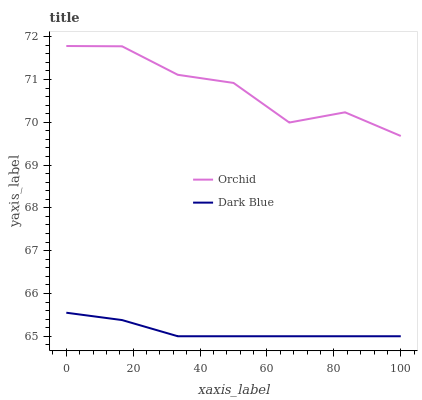Does Dark Blue have the minimum area under the curve?
Answer yes or no. Yes. Does Orchid have the maximum area under the curve?
Answer yes or no. Yes. Does Orchid have the minimum area under the curve?
Answer yes or no. No. Is Dark Blue the smoothest?
Answer yes or no. Yes. Is Orchid the roughest?
Answer yes or no. Yes. Is Orchid the smoothest?
Answer yes or no. No. Does Dark Blue have the lowest value?
Answer yes or no. Yes. Does Orchid have the lowest value?
Answer yes or no. No. Does Orchid have the highest value?
Answer yes or no. Yes. Is Dark Blue less than Orchid?
Answer yes or no. Yes. Is Orchid greater than Dark Blue?
Answer yes or no. Yes. Does Dark Blue intersect Orchid?
Answer yes or no. No. 